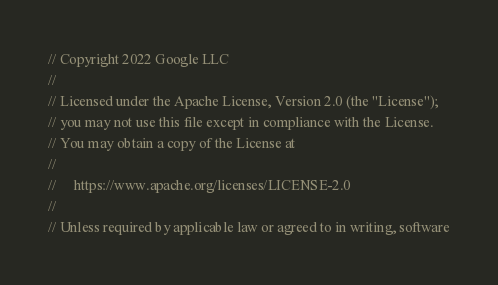<code> <loc_0><loc_0><loc_500><loc_500><_C#_>// Copyright 2022 Google LLC
//
// Licensed under the Apache License, Version 2.0 (the "License");
// you may not use this file except in compliance with the License.
// You may obtain a copy of the License at
//
//     https://www.apache.org/licenses/LICENSE-2.0
//
// Unless required by applicable law or agreed to in writing, software</code> 